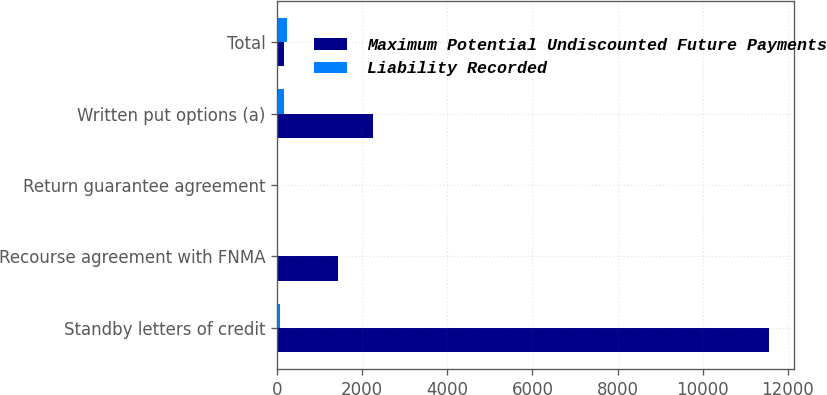<chart> <loc_0><loc_0><loc_500><loc_500><stacked_bar_chart><ecel><fcel>Standby letters of credit<fcel>Recourse agreement with FNMA<fcel>Return guarantee agreement<fcel>Written put options (a)<fcel>Total<nl><fcel>Maximum Potential Undiscounted Future Payments<fcel>11566<fcel>1432<fcel>4<fcel>2263<fcel>149<nl><fcel>Liability Recorded<fcel>65<fcel>4<fcel>4<fcel>149<fcel>222<nl></chart> 